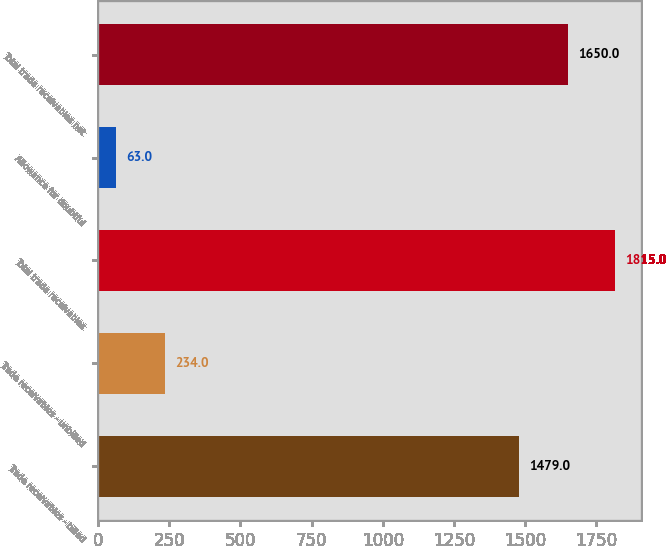<chart> <loc_0><loc_0><loc_500><loc_500><bar_chart><fcel>Trade receivables - billed<fcel>Trade receivables - unbilled<fcel>Total trade receivables<fcel>Allowance for doubtful<fcel>Total trade receivables net<nl><fcel>1479<fcel>234<fcel>1815<fcel>63<fcel>1650<nl></chart> 